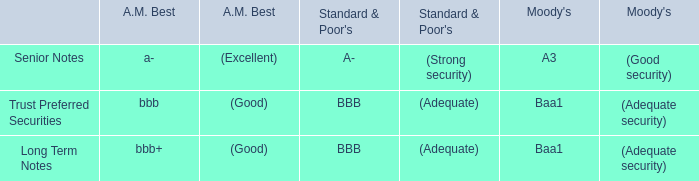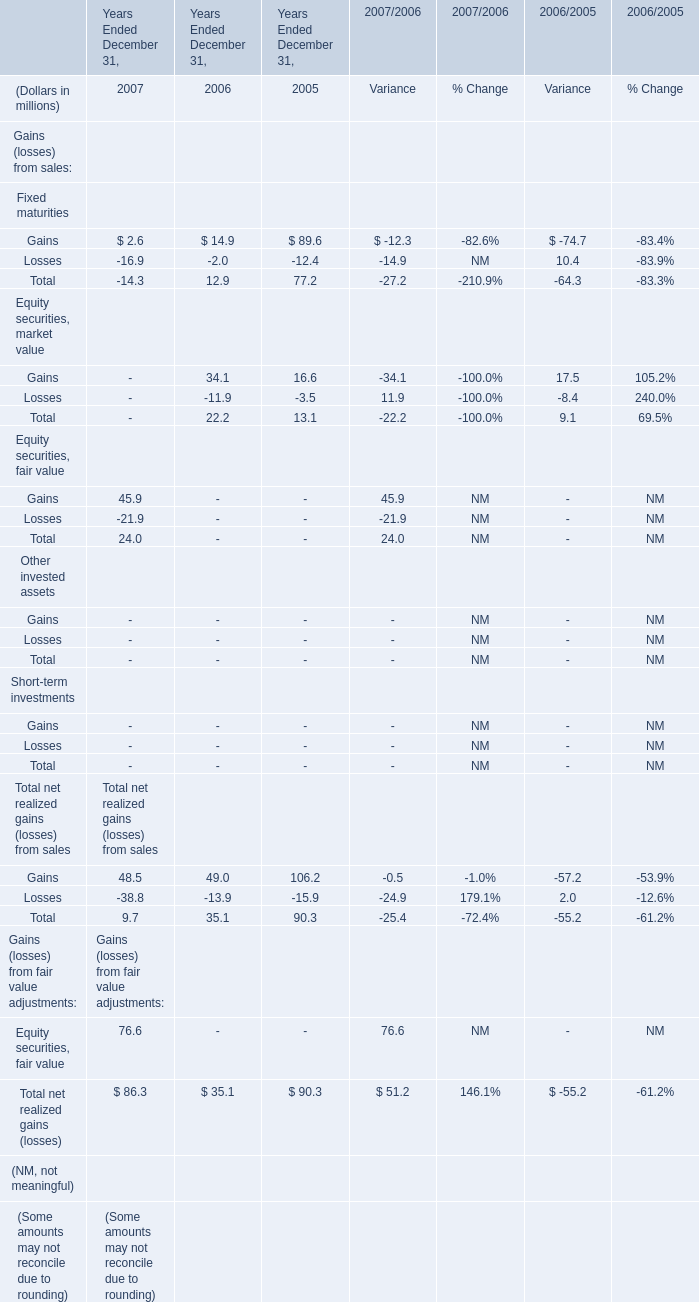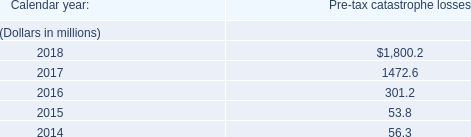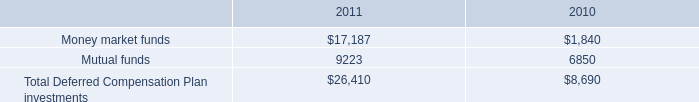what was the percentage increase of total deferred compensation plan investments from 2010 to 2011?\\n 
Computations: ((26410 - 8690) / 8690)
Answer: 2.03913. 